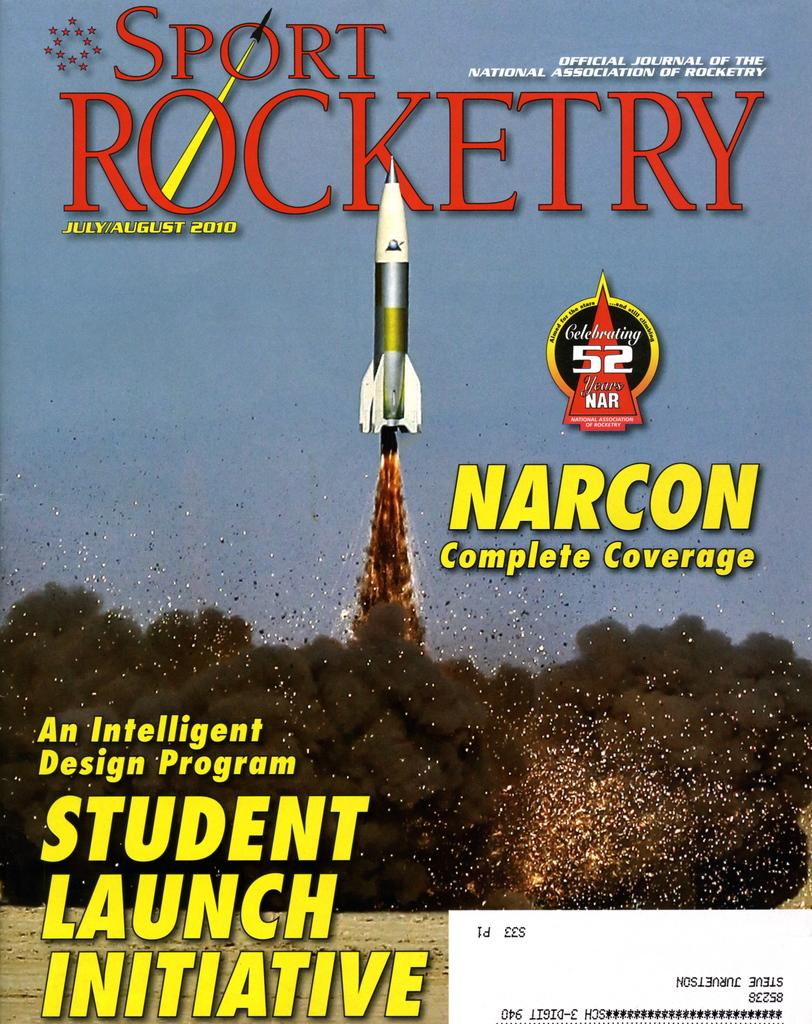What is the main subject of the image? There is a depiction of a rocket in the image. What is happening to the rocket in the image? There is smoke depicted in the image, which suggests that the rocket is taking off or has recently taken off. What can be seen on the different sides of the image? There is text written on the top, center, and bottom sides of the image. What type of camp can be seen in the image? There is no camp present in the image; it features a depiction of a rocket with smoke and text. What wish is granted by the rocket in the image? There is no indication of a wish being granted in the image; it simply depicts a rocket taking off with smoke and text. 